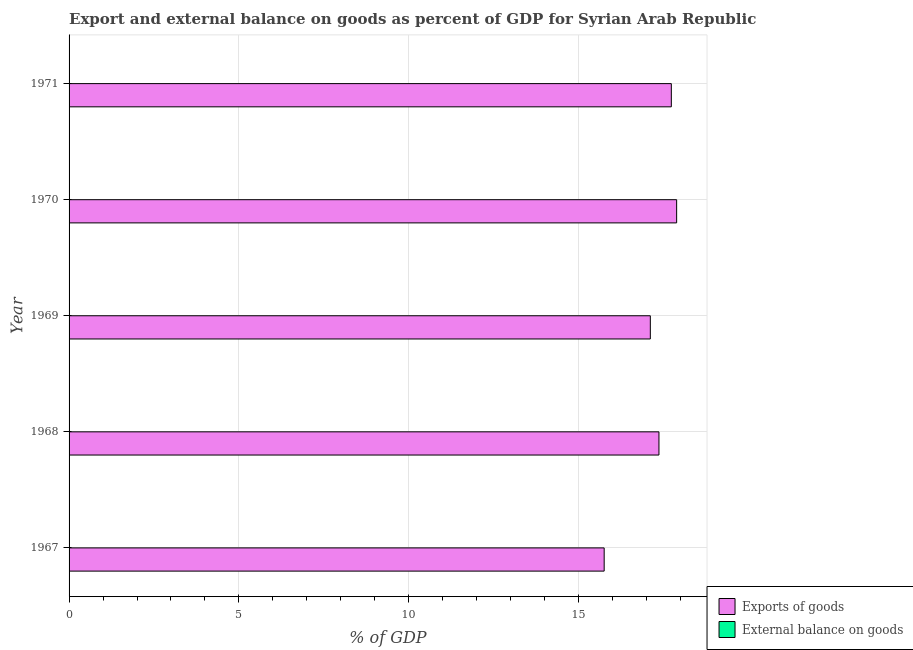Are the number of bars per tick equal to the number of legend labels?
Provide a succinct answer. No. Are the number of bars on each tick of the Y-axis equal?
Provide a short and direct response. Yes. How many bars are there on the 5th tick from the bottom?
Provide a succinct answer. 1. What is the label of the 1st group of bars from the top?
Offer a terse response. 1971. In how many cases, is the number of bars for a given year not equal to the number of legend labels?
Give a very brief answer. 5. What is the external balance on goods as percentage of gdp in 1967?
Keep it short and to the point. 0. Across all years, what is the maximum export of goods as percentage of gdp?
Offer a terse response. 17.89. Across all years, what is the minimum export of goods as percentage of gdp?
Your response must be concise. 15.75. In which year was the export of goods as percentage of gdp maximum?
Provide a short and direct response. 1970. What is the total export of goods as percentage of gdp in the graph?
Your response must be concise. 85.84. What is the difference between the export of goods as percentage of gdp in 1968 and that in 1969?
Your answer should be very brief. 0.25. What is the difference between the external balance on goods as percentage of gdp in 1968 and the export of goods as percentage of gdp in 1970?
Make the answer very short. -17.89. What is the average export of goods as percentage of gdp per year?
Offer a very short reply. 17.17. What is the ratio of the export of goods as percentage of gdp in 1969 to that in 1970?
Your answer should be compact. 0.96. Is the export of goods as percentage of gdp in 1967 less than that in 1971?
Your answer should be compact. Yes. What is the difference between the highest and the lowest export of goods as percentage of gdp?
Offer a terse response. 2.13. Is the sum of the export of goods as percentage of gdp in 1969 and 1971 greater than the maximum external balance on goods as percentage of gdp across all years?
Ensure brevity in your answer.  Yes. How many bars are there?
Your answer should be compact. 5. Are all the bars in the graph horizontal?
Keep it short and to the point. Yes. What is the difference between two consecutive major ticks on the X-axis?
Your answer should be very brief. 5. Does the graph contain any zero values?
Provide a short and direct response. Yes. Does the graph contain grids?
Offer a terse response. Yes. How are the legend labels stacked?
Offer a terse response. Vertical. What is the title of the graph?
Offer a terse response. Export and external balance on goods as percent of GDP for Syrian Arab Republic. What is the label or title of the X-axis?
Your response must be concise. % of GDP. What is the % of GDP of Exports of goods in 1967?
Your answer should be compact. 15.75. What is the % of GDP of Exports of goods in 1968?
Keep it short and to the point. 17.36. What is the % of GDP in Exports of goods in 1969?
Provide a succinct answer. 17.11. What is the % of GDP of External balance on goods in 1969?
Ensure brevity in your answer.  0. What is the % of GDP of Exports of goods in 1970?
Provide a succinct answer. 17.89. What is the % of GDP in Exports of goods in 1971?
Make the answer very short. 17.73. What is the % of GDP in External balance on goods in 1971?
Offer a very short reply. 0. Across all years, what is the maximum % of GDP in Exports of goods?
Your answer should be compact. 17.89. Across all years, what is the minimum % of GDP in Exports of goods?
Offer a terse response. 15.75. What is the total % of GDP of Exports of goods in the graph?
Provide a succinct answer. 85.84. What is the difference between the % of GDP in Exports of goods in 1967 and that in 1968?
Provide a succinct answer. -1.61. What is the difference between the % of GDP of Exports of goods in 1967 and that in 1969?
Give a very brief answer. -1.36. What is the difference between the % of GDP of Exports of goods in 1967 and that in 1970?
Give a very brief answer. -2.13. What is the difference between the % of GDP in Exports of goods in 1967 and that in 1971?
Offer a terse response. -1.98. What is the difference between the % of GDP in Exports of goods in 1968 and that in 1969?
Your answer should be compact. 0.25. What is the difference between the % of GDP of Exports of goods in 1968 and that in 1970?
Give a very brief answer. -0.52. What is the difference between the % of GDP of Exports of goods in 1968 and that in 1971?
Keep it short and to the point. -0.36. What is the difference between the % of GDP in Exports of goods in 1969 and that in 1970?
Offer a terse response. -0.77. What is the difference between the % of GDP in Exports of goods in 1969 and that in 1971?
Give a very brief answer. -0.62. What is the difference between the % of GDP of Exports of goods in 1970 and that in 1971?
Offer a very short reply. 0.16. What is the average % of GDP of Exports of goods per year?
Provide a short and direct response. 17.17. What is the average % of GDP in External balance on goods per year?
Keep it short and to the point. 0. What is the ratio of the % of GDP in Exports of goods in 1967 to that in 1968?
Your answer should be compact. 0.91. What is the ratio of the % of GDP of Exports of goods in 1967 to that in 1969?
Your answer should be very brief. 0.92. What is the ratio of the % of GDP of Exports of goods in 1967 to that in 1970?
Provide a short and direct response. 0.88. What is the ratio of the % of GDP of Exports of goods in 1967 to that in 1971?
Offer a terse response. 0.89. What is the ratio of the % of GDP in Exports of goods in 1968 to that in 1969?
Provide a short and direct response. 1.01. What is the ratio of the % of GDP of Exports of goods in 1968 to that in 1970?
Provide a short and direct response. 0.97. What is the ratio of the % of GDP of Exports of goods in 1968 to that in 1971?
Give a very brief answer. 0.98. What is the ratio of the % of GDP of Exports of goods in 1969 to that in 1970?
Provide a short and direct response. 0.96. What is the ratio of the % of GDP of Exports of goods in 1969 to that in 1971?
Give a very brief answer. 0.97. What is the ratio of the % of GDP of Exports of goods in 1970 to that in 1971?
Offer a terse response. 1.01. What is the difference between the highest and the second highest % of GDP of Exports of goods?
Give a very brief answer. 0.16. What is the difference between the highest and the lowest % of GDP in Exports of goods?
Your response must be concise. 2.13. 